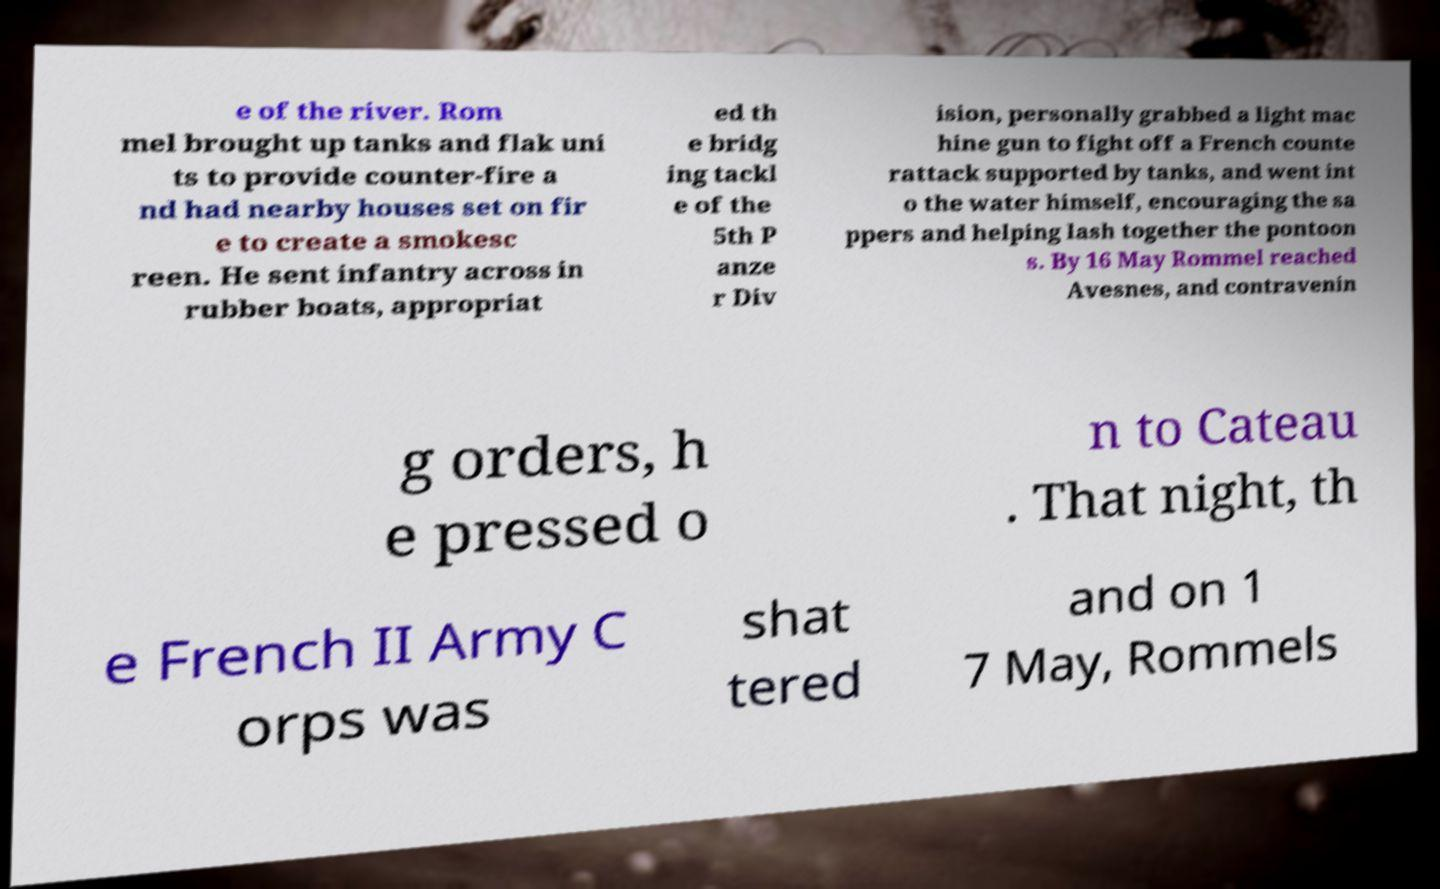Could you extract and type out the text from this image? e of the river. Rom mel brought up tanks and flak uni ts to provide counter-fire a nd had nearby houses set on fir e to create a smokesc reen. He sent infantry across in rubber boats, appropriat ed th e bridg ing tackl e of the 5th P anze r Div ision, personally grabbed a light mac hine gun to fight off a French counte rattack supported by tanks, and went int o the water himself, encouraging the sa ppers and helping lash together the pontoon s. By 16 May Rommel reached Avesnes, and contravenin g orders, h e pressed o n to Cateau . That night, th e French II Army C orps was shat tered and on 1 7 May, Rommels 